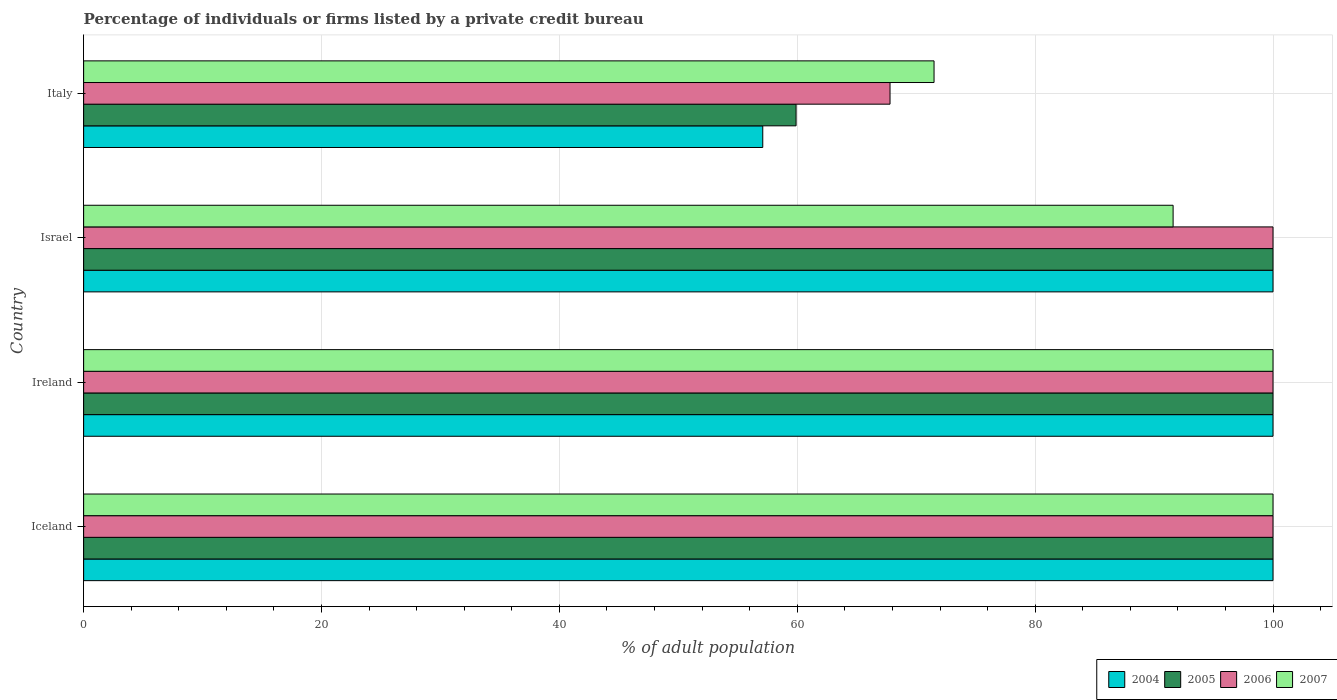How many different coloured bars are there?
Give a very brief answer. 4. Are the number of bars on each tick of the Y-axis equal?
Provide a succinct answer. Yes. How many bars are there on the 2nd tick from the top?
Your answer should be compact. 4. What is the label of the 2nd group of bars from the top?
Offer a very short reply. Israel. In how many cases, is the number of bars for a given country not equal to the number of legend labels?
Provide a succinct answer. 0. What is the percentage of population listed by a private credit bureau in 2005 in Italy?
Your answer should be compact. 59.9. Across all countries, what is the maximum percentage of population listed by a private credit bureau in 2006?
Make the answer very short. 100. Across all countries, what is the minimum percentage of population listed by a private credit bureau in 2004?
Make the answer very short. 57.1. In which country was the percentage of population listed by a private credit bureau in 2007 minimum?
Your response must be concise. Italy. What is the total percentage of population listed by a private credit bureau in 2007 in the graph?
Offer a very short reply. 363.1. What is the difference between the percentage of population listed by a private credit bureau in 2007 in Ireland and that in Israel?
Make the answer very short. 8.4. What is the average percentage of population listed by a private credit bureau in 2004 per country?
Offer a very short reply. 89.28. What is the difference between the percentage of population listed by a private credit bureau in 2007 and percentage of population listed by a private credit bureau in 2005 in Ireland?
Keep it short and to the point. 0. In how many countries, is the percentage of population listed by a private credit bureau in 2005 greater than 80 %?
Give a very brief answer. 3. What is the ratio of the percentage of population listed by a private credit bureau in 2004 in Israel to that in Italy?
Ensure brevity in your answer.  1.75. What is the difference between the highest and the lowest percentage of population listed by a private credit bureau in 2006?
Your response must be concise. 32.2. In how many countries, is the percentage of population listed by a private credit bureau in 2004 greater than the average percentage of population listed by a private credit bureau in 2004 taken over all countries?
Offer a very short reply. 3. What does the 2nd bar from the top in Iceland represents?
Give a very brief answer. 2006. Are all the bars in the graph horizontal?
Provide a short and direct response. Yes. How many countries are there in the graph?
Your answer should be compact. 4. What is the difference between two consecutive major ticks on the X-axis?
Your response must be concise. 20. Are the values on the major ticks of X-axis written in scientific E-notation?
Keep it short and to the point. No. Where does the legend appear in the graph?
Keep it short and to the point. Bottom right. How many legend labels are there?
Your response must be concise. 4. What is the title of the graph?
Your answer should be compact. Percentage of individuals or firms listed by a private credit bureau. What is the label or title of the X-axis?
Offer a terse response. % of adult population. What is the % of adult population of 2005 in Iceland?
Your response must be concise. 100. What is the % of adult population of 2007 in Iceland?
Keep it short and to the point. 100. What is the % of adult population in 2007 in Ireland?
Give a very brief answer. 100. What is the % of adult population in 2005 in Israel?
Make the answer very short. 100. What is the % of adult population of 2006 in Israel?
Offer a very short reply. 100. What is the % of adult population in 2007 in Israel?
Your response must be concise. 91.6. What is the % of adult population in 2004 in Italy?
Your response must be concise. 57.1. What is the % of adult population in 2005 in Italy?
Your answer should be compact. 59.9. What is the % of adult population in 2006 in Italy?
Ensure brevity in your answer.  67.8. What is the % of adult population in 2007 in Italy?
Your answer should be very brief. 71.5. Across all countries, what is the maximum % of adult population of 2005?
Keep it short and to the point. 100. Across all countries, what is the maximum % of adult population in 2006?
Ensure brevity in your answer.  100. Across all countries, what is the minimum % of adult population in 2004?
Make the answer very short. 57.1. Across all countries, what is the minimum % of adult population of 2005?
Your answer should be very brief. 59.9. Across all countries, what is the minimum % of adult population of 2006?
Your answer should be compact. 67.8. Across all countries, what is the minimum % of adult population in 2007?
Provide a short and direct response. 71.5. What is the total % of adult population in 2004 in the graph?
Your response must be concise. 357.1. What is the total % of adult population in 2005 in the graph?
Give a very brief answer. 359.9. What is the total % of adult population in 2006 in the graph?
Provide a short and direct response. 367.8. What is the total % of adult population in 2007 in the graph?
Your response must be concise. 363.1. What is the difference between the % of adult population of 2004 in Iceland and that in Ireland?
Make the answer very short. 0. What is the difference between the % of adult population in 2005 in Iceland and that in Ireland?
Offer a terse response. 0. What is the difference between the % of adult population in 2006 in Iceland and that in Ireland?
Offer a terse response. 0. What is the difference between the % of adult population of 2007 in Iceland and that in Ireland?
Make the answer very short. 0. What is the difference between the % of adult population of 2004 in Iceland and that in Israel?
Provide a short and direct response. 0. What is the difference between the % of adult population of 2005 in Iceland and that in Israel?
Provide a succinct answer. 0. What is the difference between the % of adult population of 2007 in Iceland and that in Israel?
Offer a terse response. 8.4. What is the difference between the % of adult population of 2004 in Iceland and that in Italy?
Provide a succinct answer. 42.9. What is the difference between the % of adult population in 2005 in Iceland and that in Italy?
Your response must be concise. 40.1. What is the difference between the % of adult population in 2006 in Iceland and that in Italy?
Provide a short and direct response. 32.2. What is the difference between the % of adult population of 2007 in Iceland and that in Italy?
Your answer should be compact. 28.5. What is the difference between the % of adult population of 2004 in Ireland and that in Italy?
Provide a short and direct response. 42.9. What is the difference between the % of adult population of 2005 in Ireland and that in Italy?
Provide a succinct answer. 40.1. What is the difference between the % of adult population of 2006 in Ireland and that in Italy?
Provide a short and direct response. 32.2. What is the difference between the % of adult population of 2007 in Ireland and that in Italy?
Offer a very short reply. 28.5. What is the difference between the % of adult population of 2004 in Israel and that in Italy?
Provide a short and direct response. 42.9. What is the difference between the % of adult population of 2005 in Israel and that in Italy?
Your answer should be very brief. 40.1. What is the difference between the % of adult population of 2006 in Israel and that in Italy?
Your answer should be compact. 32.2. What is the difference between the % of adult population of 2007 in Israel and that in Italy?
Your response must be concise. 20.1. What is the difference between the % of adult population in 2005 in Iceland and the % of adult population in 2006 in Ireland?
Keep it short and to the point. 0. What is the difference between the % of adult population of 2006 in Iceland and the % of adult population of 2007 in Ireland?
Provide a short and direct response. 0. What is the difference between the % of adult population in 2006 in Iceland and the % of adult population in 2007 in Israel?
Your answer should be very brief. 8.4. What is the difference between the % of adult population in 2004 in Iceland and the % of adult population in 2005 in Italy?
Your answer should be compact. 40.1. What is the difference between the % of adult population of 2004 in Iceland and the % of adult population of 2006 in Italy?
Offer a very short reply. 32.2. What is the difference between the % of adult population of 2004 in Iceland and the % of adult population of 2007 in Italy?
Keep it short and to the point. 28.5. What is the difference between the % of adult population of 2005 in Iceland and the % of adult population of 2006 in Italy?
Offer a terse response. 32.2. What is the difference between the % of adult population of 2006 in Iceland and the % of adult population of 2007 in Italy?
Your answer should be very brief. 28.5. What is the difference between the % of adult population of 2004 in Ireland and the % of adult population of 2006 in Israel?
Offer a terse response. 0. What is the difference between the % of adult population in 2004 in Ireland and the % of adult population in 2007 in Israel?
Your answer should be compact. 8.4. What is the difference between the % of adult population of 2006 in Ireland and the % of adult population of 2007 in Israel?
Offer a terse response. 8.4. What is the difference between the % of adult population in 2004 in Ireland and the % of adult population in 2005 in Italy?
Your answer should be very brief. 40.1. What is the difference between the % of adult population of 2004 in Ireland and the % of adult population of 2006 in Italy?
Ensure brevity in your answer.  32.2. What is the difference between the % of adult population in 2004 in Ireland and the % of adult population in 2007 in Italy?
Keep it short and to the point. 28.5. What is the difference between the % of adult population in 2005 in Ireland and the % of adult population in 2006 in Italy?
Your response must be concise. 32.2. What is the difference between the % of adult population in 2005 in Ireland and the % of adult population in 2007 in Italy?
Make the answer very short. 28.5. What is the difference between the % of adult population of 2006 in Ireland and the % of adult population of 2007 in Italy?
Your response must be concise. 28.5. What is the difference between the % of adult population in 2004 in Israel and the % of adult population in 2005 in Italy?
Make the answer very short. 40.1. What is the difference between the % of adult population in 2004 in Israel and the % of adult population in 2006 in Italy?
Ensure brevity in your answer.  32.2. What is the difference between the % of adult population in 2005 in Israel and the % of adult population in 2006 in Italy?
Keep it short and to the point. 32.2. What is the difference between the % of adult population of 2005 in Israel and the % of adult population of 2007 in Italy?
Your response must be concise. 28.5. What is the difference between the % of adult population in 2006 in Israel and the % of adult population in 2007 in Italy?
Provide a short and direct response. 28.5. What is the average % of adult population of 2004 per country?
Your response must be concise. 89.28. What is the average % of adult population in 2005 per country?
Offer a very short reply. 89.97. What is the average % of adult population of 2006 per country?
Provide a short and direct response. 91.95. What is the average % of adult population in 2007 per country?
Give a very brief answer. 90.78. What is the difference between the % of adult population in 2004 and % of adult population in 2005 in Iceland?
Offer a terse response. 0. What is the difference between the % of adult population of 2005 and % of adult population of 2006 in Iceland?
Your answer should be compact. 0. What is the difference between the % of adult population in 2005 and % of adult population in 2007 in Iceland?
Provide a short and direct response. 0. What is the difference between the % of adult population of 2004 and % of adult population of 2005 in Ireland?
Provide a succinct answer. 0. What is the difference between the % of adult population in 2004 and % of adult population in 2006 in Ireland?
Your response must be concise. 0. What is the difference between the % of adult population in 2004 and % of adult population in 2007 in Ireland?
Keep it short and to the point. 0. What is the difference between the % of adult population of 2005 and % of adult population of 2006 in Ireland?
Your answer should be compact. 0. What is the difference between the % of adult population in 2005 and % of adult population in 2007 in Ireland?
Make the answer very short. 0. What is the difference between the % of adult population of 2006 and % of adult population of 2007 in Ireland?
Your response must be concise. 0. What is the difference between the % of adult population of 2005 and % of adult population of 2006 in Israel?
Your response must be concise. 0. What is the difference between the % of adult population of 2005 and % of adult population of 2007 in Israel?
Make the answer very short. 8.4. What is the difference between the % of adult population in 2004 and % of adult population in 2006 in Italy?
Keep it short and to the point. -10.7. What is the difference between the % of adult population of 2004 and % of adult population of 2007 in Italy?
Offer a very short reply. -14.4. What is the difference between the % of adult population in 2005 and % of adult population in 2007 in Italy?
Your answer should be compact. -11.6. What is the ratio of the % of adult population of 2005 in Iceland to that in Ireland?
Your response must be concise. 1. What is the ratio of the % of adult population in 2007 in Iceland to that in Ireland?
Ensure brevity in your answer.  1. What is the ratio of the % of adult population of 2004 in Iceland to that in Israel?
Provide a short and direct response. 1. What is the ratio of the % of adult population in 2005 in Iceland to that in Israel?
Provide a short and direct response. 1. What is the ratio of the % of adult population in 2007 in Iceland to that in Israel?
Provide a short and direct response. 1.09. What is the ratio of the % of adult population of 2004 in Iceland to that in Italy?
Offer a very short reply. 1.75. What is the ratio of the % of adult population in 2005 in Iceland to that in Italy?
Your answer should be very brief. 1.67. What is the ratio of the % of adult population of 2006 in Iceland to that in Italy?
Make the answer very short. 1.47. What is the ratio of the % of adult population of 2007 in Iceland to that in Italy?
Offer a terse response. 1.4. What is the ratio of the % of adult population in 2004 in Ireland to that in Israel?
Offer a very short reply. 1. What is the ratio of the % of adult population in 2005 in Ireland to that in Israel?
Offer a terse response. 1. What is the ratio of the % of adult population in 2006 in Ireland to that in Israel?
Ensure brevity in your answer.  1. What is the ratio of the % of adult population in 2007 in Ireland to that in Israel?
Make the answer very short. 1.09. What is the ratio of the % of adult population in 2004 in Ireland to that in Italy?
Make the answer very short. 1.75. What is the ratio of the % of adult population of 2005 in Ireland to that in Italy?
Provide a succinct answer. 1.67. What is the ratio of the % of adult population of 2006 in Ireland to that in Italy?
Offer a very short reply. 1.47. What is the ratio of the % of adult population in 2007 in Ireland to that in Italy?
Make the answer very short. 1.4. What is the ratio of the % of adult population of 2004 in Israel to that in Italy?
Your answer should be compact. 1.75. What is the ratio of the % of adult population of 2005 in Israel to that in Italy?
Keep it short and to the point. 1.67. What is the ratio of the % of adult population in 2006 in Israel to that in Italy?
Provide a short and direct response. 1.47. What is the ratio of the % of adult population in 2007 in Israel to that in Italy?
Make the answer very short. 1.28. What is the difference between the highest and the second highest % of adult population of 2005?
Make the answer very short. 0. What is the difference between the highest and the second highest % of adult population of 2007?
Your response must be concise. 0. What is the difference between the highest and the lowest % of adult population in 2004?
Your response must be concise. 42.9. What is the difference between the highest and the lowest % of adult population of 2005?
Your answer should be very brief. 40.1. What is the difference between the highest and the lowest % of adult population of 2006?
Ensure brevity in your answer.  32.2. What is the difference between the highest and the lowest % of adult population in 2007?
Offer a very short reply. 28.5. 